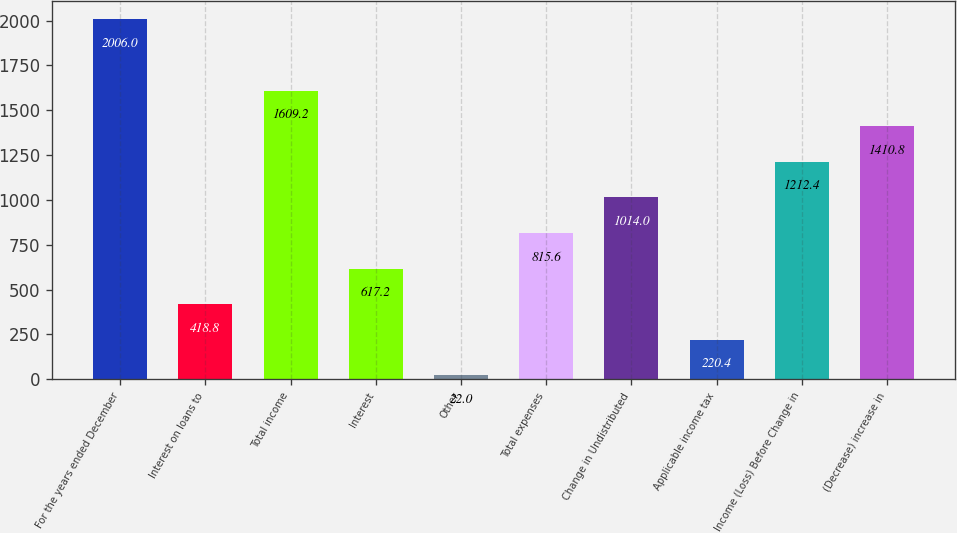Convert chart to OTSL. <chart><loc_0><loc_0><loc_500><loc_500><bar_chart><fcel>For the years ended December<fcel>Interest on loans to<fcel>Total income<fcel>Interest<fcel>Other<fcel>Total expenses<fcel>Change in Undistributed<fcel>Applicable income tax<fcel>Income (Loss) Before Change in<fcel>(Decrease) increase in<nl><fcel>2006<fcel>418.8<fcel>1609.2<fcel>617.2<fcel>22<fcel>815.6<fcel>1014<fcel>220.4<fcel>1212.4<fcel>1410.8<nl></chart> 